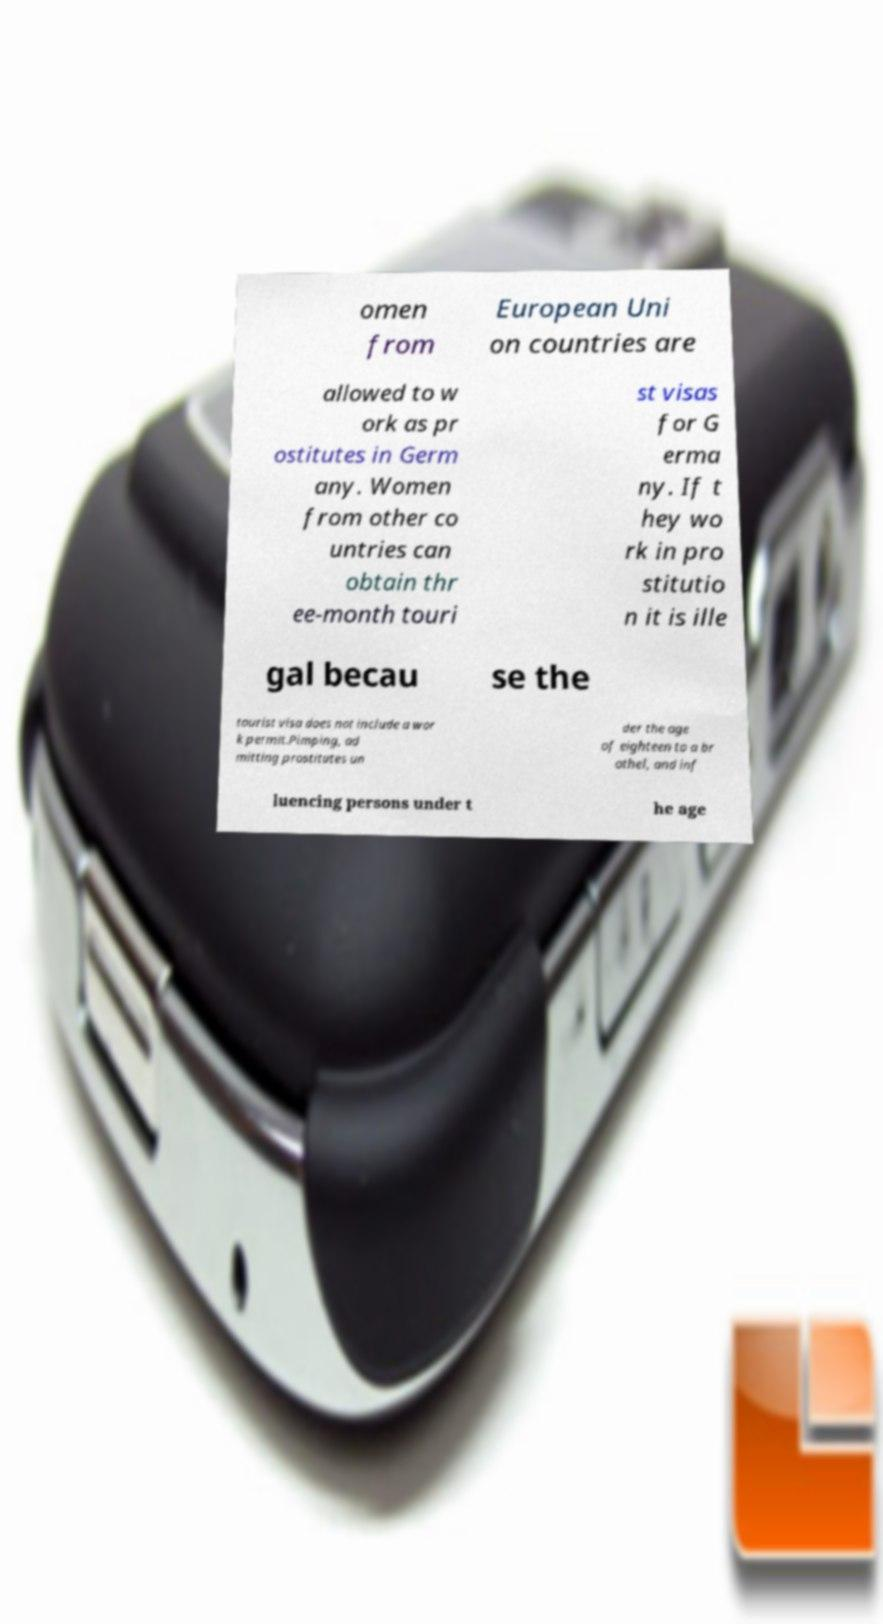Can you accurately transcribe the text from the provided image for me? omen from European Uni on countries are allowed to w ork as pr ostitutes in Germ any. Women from other co untries can obtain thr ee-month touri st visas for G erma ny. If t hey wo rk in pro stitutio n it is ille gal becau se the tourist visa does not include a wor k permit.Pimping, ad mitting prostitutes un der the age of eighteen to a br othel, and inf luencing persons under t he age 